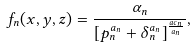<formula> <loc_0><loc_0><loc_500><loc_500>f _ { n } ( x , y , z ) = \frac { \alpha _ { n } } { \left [ p _ { n } ^ { a _ { n } } + \delta _ { n } ^ { a _ { n } } \right ] ^ { \frac { a c _ { n } } { a _ { n } } } } ,</formula> 